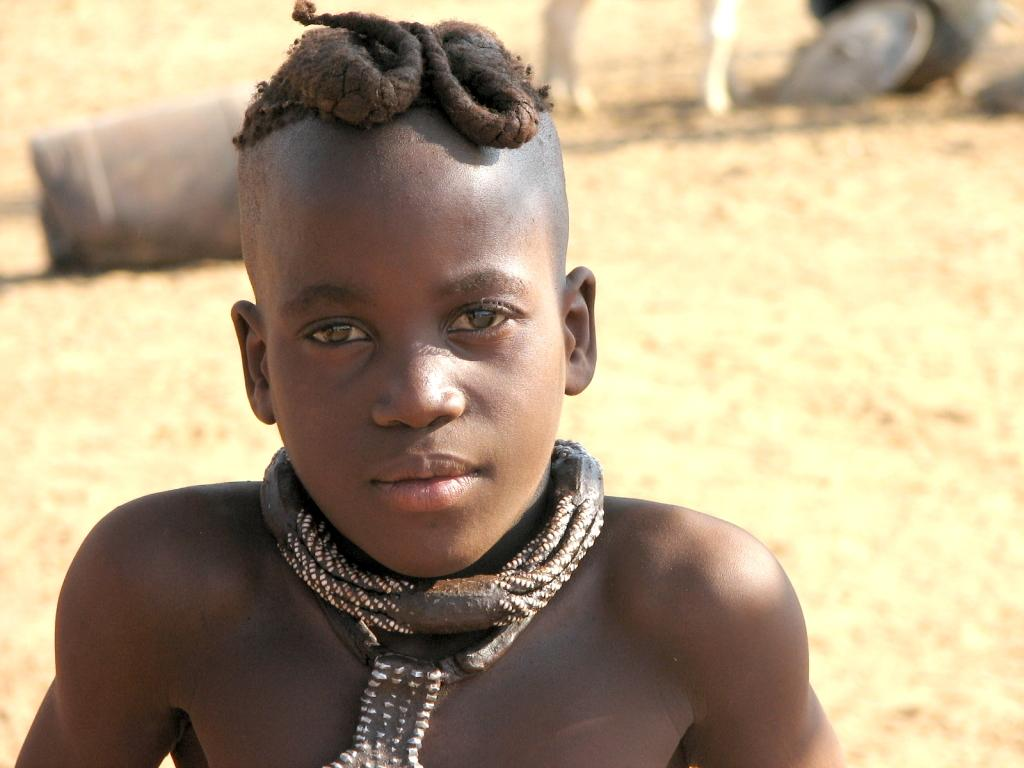Who is the main subject in the picture? There is a boy in the picture. What is the boy wearing in the picture? The boy is wearing an ornament around his neck. What can be seen in the background of the picture? There are objects visible in the background of the picture. What is the surface at the bottom of the picture? There is sand at the bottom of the picture. What type of education can be seen in the aftermath of the picture? There is no reference to education or an aftermath in the picture; it simply shows a boy wearing an ornament and standing on sand. 